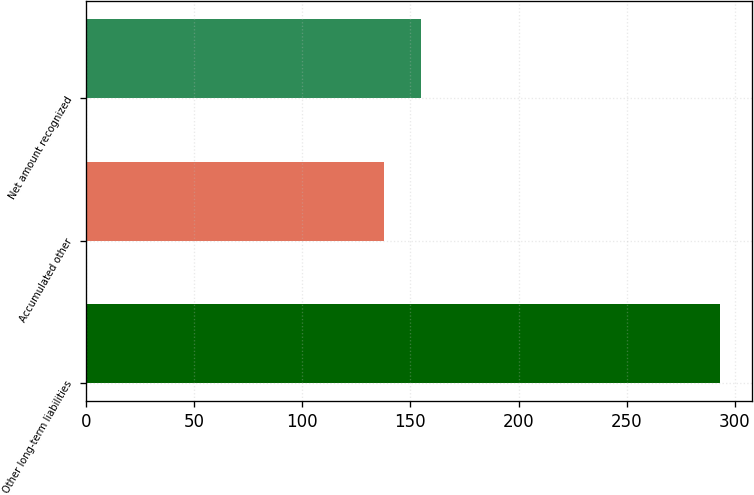Convert chart to OTSL. <chart><loc_0><loc_0><loc_500><loc_500><bar_chart><fcel>Other long-term liabilities<fcel>Accumulated other<fcel>Net amount recognized<nl><fcel>293<fcel>138<fcel>155<nl></chart> 